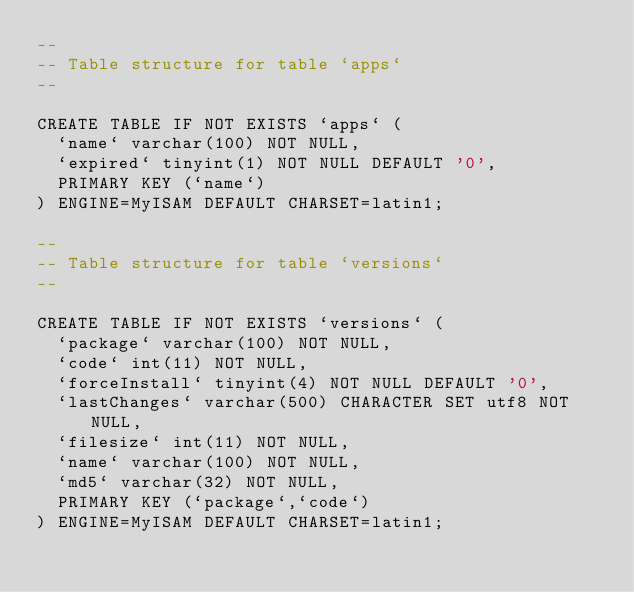<code> <loc_0><loc_0><loc_500><loc_500><_SQL_>--
-- Table structure for table `apps`
--

CREATE TABLE IF NOT EXISTS `apps` (
  `name` varchar(100) NOT NULL,
  `expired` tinyint(1) NOT NULL DEFAULT '0',
  PRIMARY KEY (`name`)
) ENGINE=MyISAM DEFAULT CHARSET=latin1;

--
-- Table structure for table `versions`
--

CREATE TABLE IF NOT EXISTS `versions` (
  `package` varchar(100) NOT NULL,
  `code` int(11) NOT NULL,
  `forceInstall` tinyint(4) NOT NULL DEFAULT '0',
  `lastChanges` varchar(500) CHARACTER SET utf8 NOT NULL,
  `filesize` int(11) NOT NULL,
  `name` varchar(100) NOT NULL,
  `md5` varchar(32) NOT NULL,
  PRIMARY KEY (`package`,`code`)
) ENGINE=MyISAM DEFAULT CHARSET=latin1;</code> 